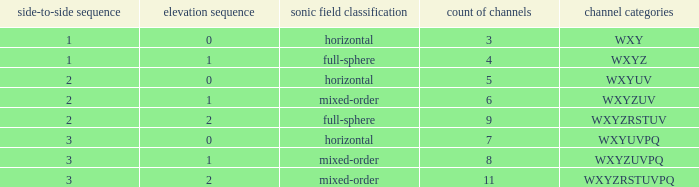If the channels is wxyzuv, what is the number of channels? 6.0. Could you parse the entire table? {'header': ['side-to-side sequence', 'elevation sequence', 'sonic field classification', 'count of channels', 'channel categories'], 'rows': [['1', '0', 'horizontal', '3', 'WXY'], ['1', '1', 'full-sphere', '4', 'WXYZ'], ['2', '0', 'horizontal', '5', 'WXYUV'], ['2', '1', 'mixed-order', '6', 'WXYZUV'], ['2', '2', 'full-sphere', '9', 'WXYZRSTUV'], ['3', '0', 'horizontal', '7', 'WXYUVPQ'], ['3', '1', 'mixed-order', '8', 'WXYZUVPQ'], ['3', '2', 'mixed-order', '11', 'WXYZRSTUVPQ']]} 